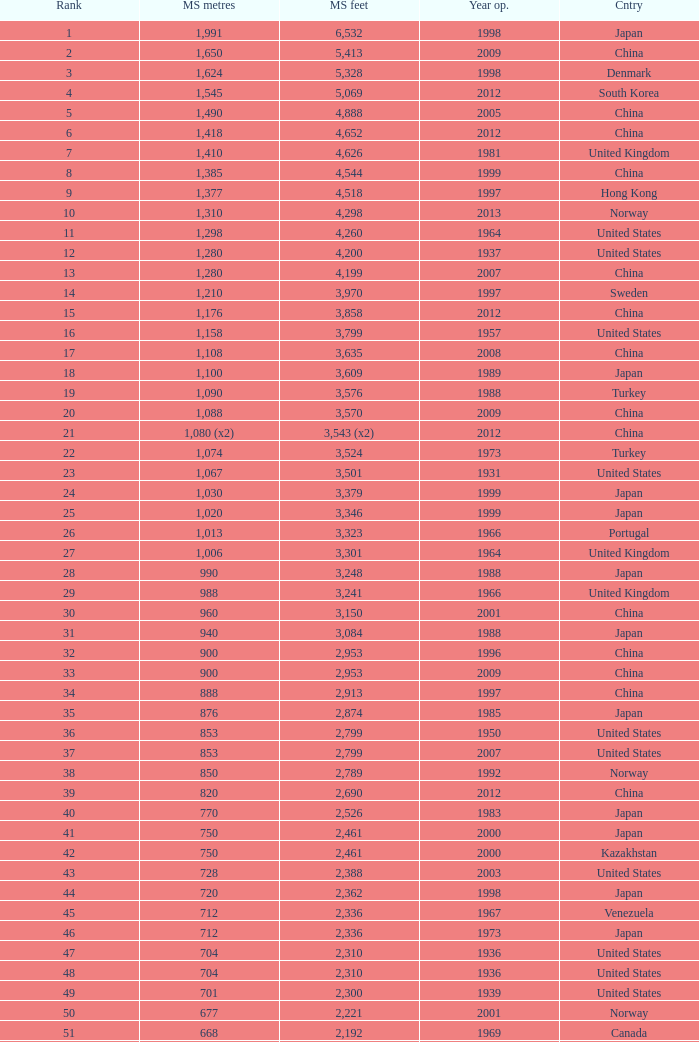What is the utmost rank from the year surpassing 2010 with 430 chief span metres? 94.0. 